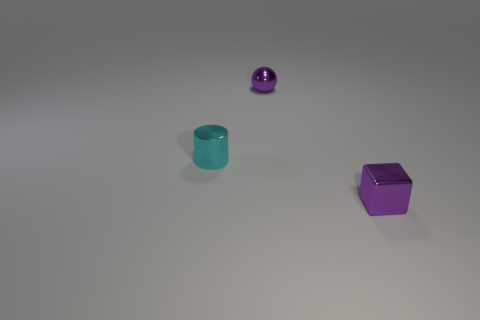There is a purple metallic thing that is behind the cyan object; is its size the same as the thing that is to the right of the ball?
Your response must be concise. Yes. Are there an equal number of tiny cyan shiny things that are left of the tiny cyan shiny object and shiny cylinders?
Offer a terse response. No. There is a cyan metallic object; is its size the same as the purple thing behind the purple block?
Your answer should be very brief. Yes. How many small purple spheres are the same material as the purple cube?
Ensure brevity in your answer.  1. Do the purple metallic cube and the cylinder have the same size?
Provide a short and direct response. Yes. Are there any other things of the same color as the small metallic cylinder?
Offer a very short reply. No. There is a object that is both to the right of the cyan thing and on the left side of the small cube; what is its shape?
Provide a succinct answer. Sphere. What is the size of the object behind the small cyan metallic cylinder?
Your response must be concise. Small. There is a purple metallic thing that is right of the purple metal thing that is left of the purple metal cube; how many small cylinders are behind it?
Your answer should be compact. 1. Are there any metallic objects in front of the metal cylinder?
Provide a succinct answer. Yes. 